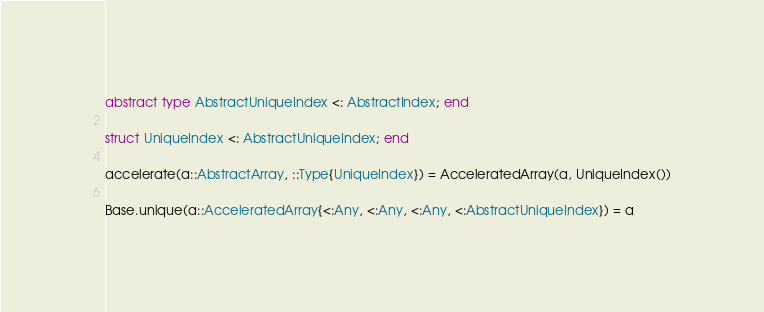Convert code to text. <code><loc_0><loc_0><loc_500><loc_500><_Julia_>abstract type AbstractUniqueIndex <: AbstractIndex; end

struct UniqueIndex <: AbstractUniqueIndex; end

accelerate(a::AbstractArray, ::Type{UniqueIndex}) = AcceleratedArray(a, UniqueIndex())

Base.unique(a::AcceleratedArray{<:Any, <:Any, <:Any, <:AbstractUniqueIndex}) = a
</code> 